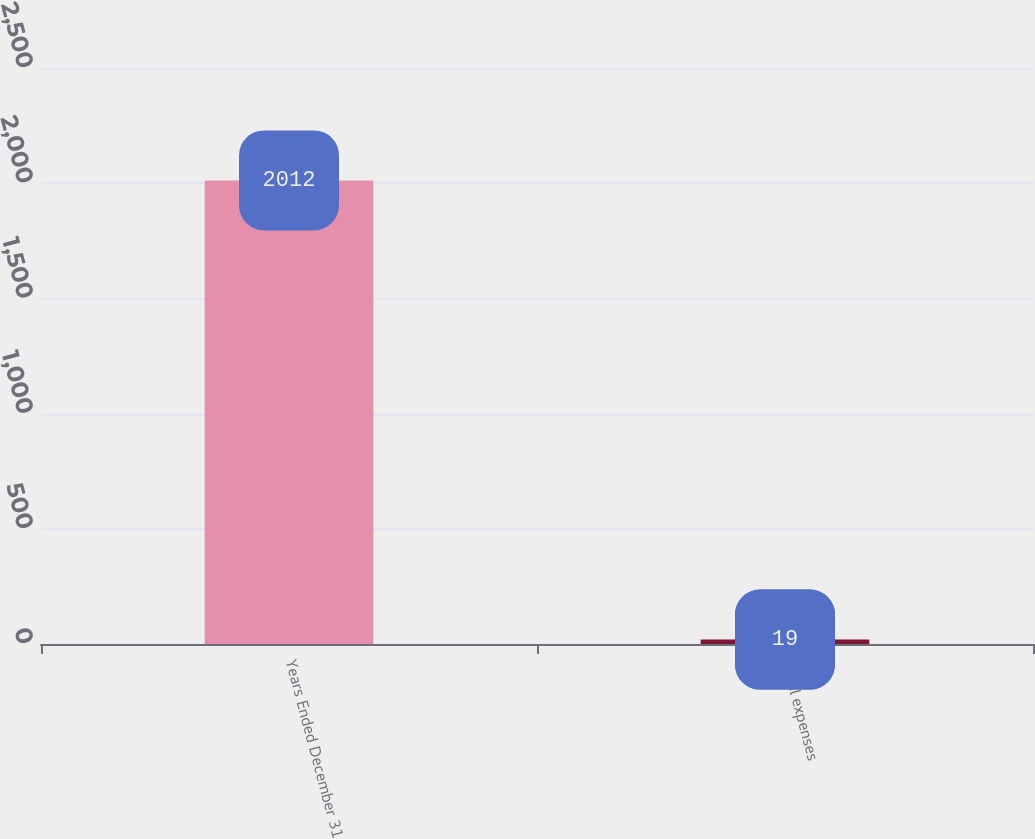Convert chart to OTSL. <chart><loc_0><loc_0><loc_500><loc_500><bar_chart><fcel>Years Ended December 31<fcel>Total expenses<nl><fcel>2012<fcel>19<nl></chart> 